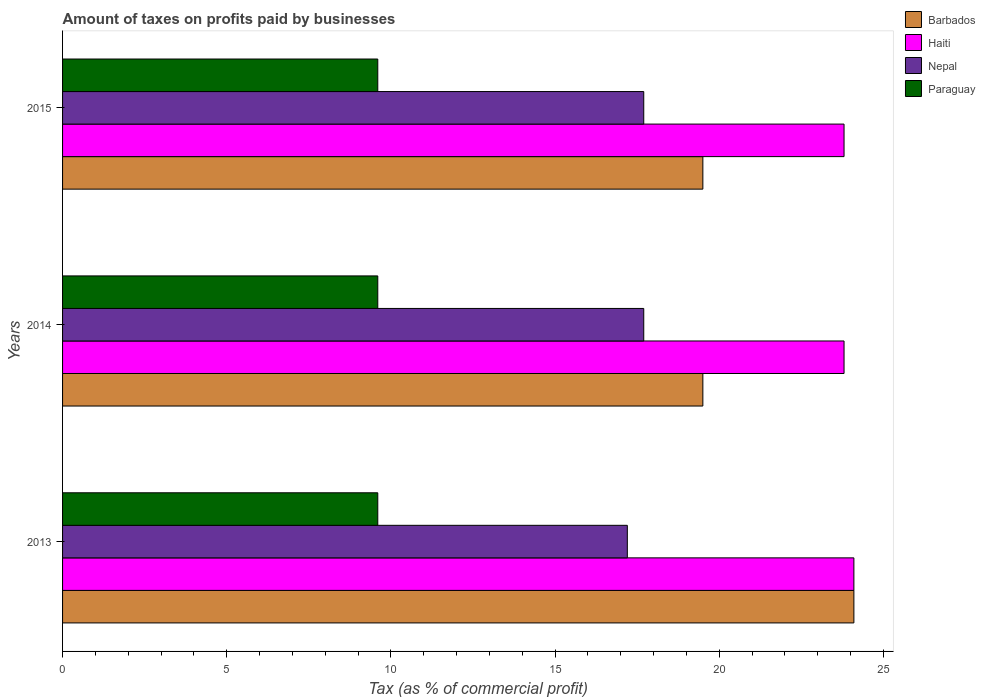Are the number of bars on each tick of the Y-axis equal?
Offer a very short reply. Yes. How many bars are there on the 2nd tick from the top?
Provide a succinct answer. 4. What is the label of the 1st group of bars from the top?
Your answer should be compact. 2015. What is the percentage of taxes paid by businesses in Barbados in 2015?
Your answer should be very brief. 19.5. Across all years, what is the maximum percentage of taxes paid by businesses in Haiti?
Offer a terse response. 24.1. Across all years, what is the minimum percentage of taxes paid by businesses in Paraguay?
Your answer should be very brief. 9.6. In which year was the percentage of taxes paid by businesses in Nepal maximum?
Give a very brief answer. 2014. What is the total percentage of taxes paid by businesses in Paraguay in the graph?
Your answer should be compact. 28.8. What is the difference between the percentage of taxes paid by businesses in Barbados in 2013 and that in 2014?
Keep it short and to the point. 4.6. What is the difference between the percentage of taxes paid by businesses in Paraguay in 2014 and the percentage of taxes paid by businesses in Barbados in 2013?
Offer a terse response. -14.5. What is the average percentage of taxes paid by businesses in Barbados per year?
Offer a terse response. 21.03. In the year 2014, what is the difference between the percentage of taxes paid by businesses in Paraguay and percentage of taxes paid by businesses in Barbados?
Your answer should be very brief. -9.9. In how many years, is the percentage of taxes paid by businesses in Paraguay greater than 24 %?
Provide a succinct answer. 0. What is the ratio of the percentage of taxes paid by businesses in Nepal in 2013 to that in 2014?
Provide a short and direct response. 0.97. Is the difference between the percentage of taxes paid by businesses in Paraguay in 2013 and 2014 greater than the difference between the percentage of taxes paid by businesses in Barbados in 2013 and 2014?
Offer a very short reply. No. What is the difference between the highest and the second highest percentage of taxes paid by businesses in Barbados?
Keep it short and to the point. 4.6. What is the difference between the highest and the lowest percentage of taxes paid by businesses in Barbados?
Offer a terse response. 4.6. In how many years, is the percentage of taxes paid by businesses in Barbados greater than the average percentage of taxes paid by businesses in Barbados taken over all years?
Make the answer very short. 1. What does the 1st bar from the top in 2013 represents?
Provide a succinct answer. Paraguay. What does the 2nd bar from the bottom in 2013 represents?
Keep it short and to the point. Haiti. How many bars are there?
Your answer should be compact. 12. How many years are there in the graph?
Your answer should be very brief. 3. What is the difference between two consecutive major ticks on the X-axis?
Provide a succinct answer. 5. Where does the legend appear in the graph?
Your answer should be very brief. Top right. How many legend labels are there?
Offer a very short reply. 4. What is the title of the graph?
Provide a short and direct response. Amount of taxes on profits paid by businesses. What is the label or title of the X-axis?
Make the answer very short. Tax (as % of commercial profit). What is the label or title of the Y-axis?
Your response must be concise. Years. What is the Tax (as % of commercial profit) in Barbados in 2013?
Your answer should be very brief. 24.1. What is the Tax (as % of commercial profit) of Haiti in 2013?
Give a very brief answer. 24.1. What is the Tax (as % of commercial profit) in Haiti in 2014?
Offer a very short reply. 23.8. What is the Tax (as % of commercial profit) of Paraguay in 2014?
Make the answer very short. 9.6. What is the Tax (as % of commercial profit) in Barbados in 2015?
Give a very brief answer. 19.5. What is the Tax (as % of commercial profit) in Haiti in 2015?
Provide a succinct answer. 23.8. Across all years, what is the maximum Tax (as % of commercial profit) in Barbados?
Provide a short and direct response. 24.1. Across all years, what is the maximum Tax (as % of commercial profit) in Haiti?
Make the answer very short. 24.1. Across all years, what is the maximum Tax (as % of commercial profit) in Paraguay?
Offer a terse response. 9.6. Across all years, what is the minimum Tax (as % of commercial profit) in Barbados?
Give a very brief answer. 19.5. Across all years, what is the minimum Tax (as % of commercial profit) of Haiti?
Make the answer very short. 23.8. Across all years, what is the minimum Tax (as % of commercial profit) in Nepal?
Keep it short and to the point. 17.2. What is the total Tax (as % of commercial profit) of Barbados in the graph?
Offer a very short reply. 63.1. What is the total Tax (as % of commercial profit) in Haiti in the graph?
Your answer should be very brief. 71.7. What is the total Tax (as % of commercial profit) of Nepal in the graph?
Keep it short and to the point. 52.6. What is the total Tax (as % of commercial profit) of Paraguay in the graph?
Your answer should be compact. 28.8. What is the difference between the Tax (as % of commercial profit) of Nepal in 2013 and that in 2014?
Make the answer very short. -0.5. What is the difference between the Tax (as % of commercial profit) of Haiti in 2013 and that in 2015?
Keep it short and to the point. 0.3. What is the difference between the Tax (as % of commercial profit) of Barbados in 2014 and that in 2015?
Offer a very short reply. 0. What is the difference between the Tax (as % of commercial profit) of Nepal in 2014 and that in 2015?
Give a very brief answer. 0. What is the difference between the Tax (as % of commercial profit) in Paraguay in 2014 and that in 2015?
Your response must be concise. 0. What is the difference between the Tax (as % of commercial profit) in Barbados in 2013 and the Tax (as % of commercial profit) in Paraguay in 2014?
Keep it short and to the point. 14.5. What is the difference between the Tax (as % of commercial profit) in Haiti in 2013 and the Tax (as % of commercial profit) in Nepal in 2014?
Offer a terse response. 6.4. What is the difference between the Tax (as % of commercial profit) of Haiti in 2013 and the Tax (as % of commercial profit) of Paraguay in 2014?
Your response must be concise. 14.5. What is the difference between the Tax (as % of commercial profit) in Nepal in 2013 and the Tax (as % of commercial profit) in Paraguay in 2014?
Make the answer very short. 7.6. What is the difference between the Tax (as % of commercial profit) of Barbados in 2013 and the Tax (as % of commercial profit) of Nepal in 2015?
Ensure brevity in your answer.  6.4. What is the difference between the Tax (as % of commercial profit) in Barbados in 2013 and the Tax (as % of commercial profit) in Paraguay in 2015?
Your answer should be compact. 14.5. What is the difference between the Tax (as % of commercial profit) in Haiti in 2013 and the Tax (as % of commercial profit) in Nepal in 2015?
Make the answer very short. 6.4. What is the difference between the Tax (as % of commercial profit) in Nepal in 2013 and the Tax (as % of commercial profit) in Paraguay in 2015?
Keep it short and to the point. 7.6. What is the difference between the Tax (as % of commercial profit) of Barbados in 2014 and the Tax (as % of commercial profit) of Haiti in 2015?
Give a very brief answer. -4.3. What is the difference between the Tax (as % of commercial profit) of Barbados in 2014 and the Tax (as % of commercial profit) of Paraguay in 2015?
Offer a very short reply. 9.9. What is the difference between the Tax (as % of commercial profit) in Haiti in 2014 and the Tax (as % of commercial profit) in Nepal in 2015?
Make the answer very short. 6.1. What is the difference between the Tax (as % of commercial profit) of Nepal in 2014 and the Tax (as % of commercial profit) of Paraguay in 2015?
Your answer should be very brief. 8.1. What is the average Tax (as % of commercial profit) of Barbados per year?
Offer a very short reply. 21.03. What is the average Tax (as % of commercial profit) of Haiti per year?
Give a very brief answer. 23.9. What is the average Tax (as % of commercial profit) of Nepal per year?
Keep it short and to the point. 17.53. In the year 2013, what is the difference between the Tax (as % of commercial profit) in Barbados and Tax (as % of commercial profit) in Haiti?
Keep it short and to the point. 0. In the year 2013, what is the difference between the Tax (as % of commercial profit) of Barbados and Tax (as % of commercial profit) of Nepal?
Make the answer very short. 6.9. In the year 2013, what is the difference between the Tax (as % of commercial profit) of Barbados and Tax (as % of commercial profit) of Paraguay?
Ensure brevity in your answer.  14.5. In the year 2014, what is the difference between the Tax (as % of commercial profit) in Barbados and Tax (as % of commercial profit) in Haiti?
Provide a short and direct response. -4.3. In the year 2014, what is the difference between the Tax (as % of commercial profit) in Barbados and Tax (as % of commercial profit) in Nepal?
Provide a succinct answer. 1.8. In the year 2014, what is the difference between the Tax (as % of commercial profit) in Haiti and Tax (as % of commercial profit) in Nepal?
Give a very brief answer. 6.1. In the year 2015, what is the difference between the Tax (as % of commercial profit) in Barbados and Tax (as % of commercial profit) in Haiti?
Your answer should be very brief. -4.3. In the year 2015, what is the difference between the Tax (as % of commercial profit) of Haiti and Tax (as % of commercial profit) of Paraguay?
Your answer should be compact. 14.2. What is the ratio of the Tax (as % of commercial profit) of Barbados in 2013 to that in 2014?
Ensure brevity in your answer.  1.24. What is the ratio of the Tax (as % of commercial profit) of Haiti in 2013 to that in 2014?
Make the answer very short. 1.01. What is the ratio of the Tax (as % of commercial profit) in Nepal in 2013 to that in 2014?
Provide a succinct answer. 0.97. What is the ratio of the Tax (as % of commercial profit) of Barbados in 2013 to that in 2015?
Your answer should be very brief. 1.24. What is the ratio of the Tax (as % of commercial profit) in Haiti in 2013 to that in 2015?
Ensure brevity in your answer.  1.01. What is the ratio of the Tax (as % of commercial profit) in Nepal in 2013 to that in 2015?
Make the answer very short. 0.97. What is the ratio of the Tax (as % of commercial profit) in Barbados in 2014 to that in 2015?
Keep it short and to the point. 1. What is the ratio of the Tax (as % of commercial profit) of Nepal in 2014 to that in 2015?
Offer a very short reply. 1. What is the difference between the highest and the second highest Tax (as % of commercial profit) in Barbados?
Your answer should be very brief. 4.6. What is the difference between the highest and the second highest Tax (as % of commercial profit) in Haiti?
Your answer should be compact. 0.3. 